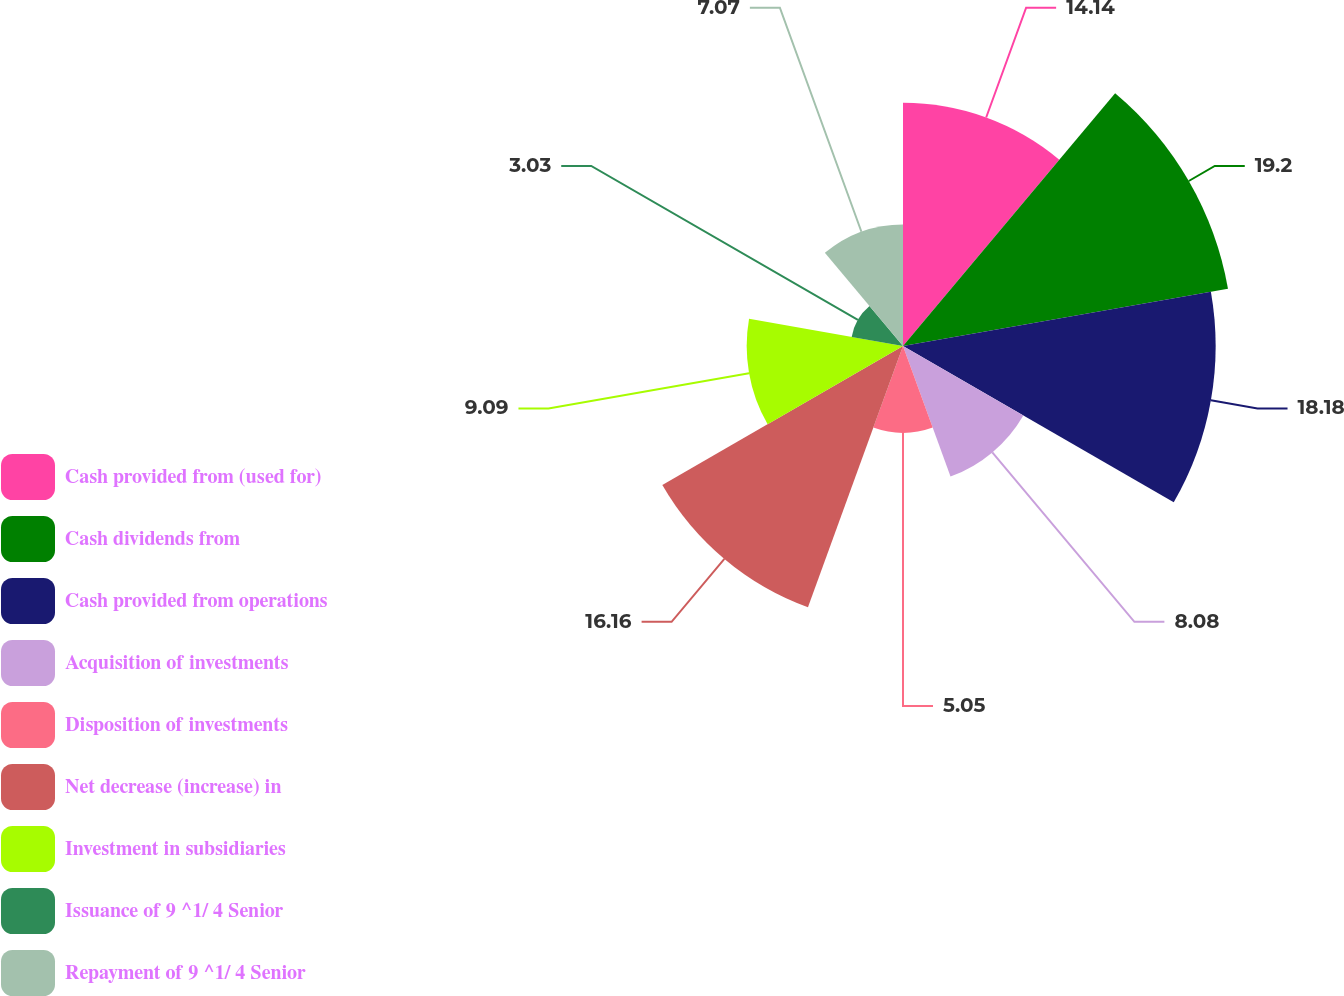<chart> <loc_0><loc_0><loc_500><loc_500><pie_chart><fcel>Cash provided from (used for)<fcel>Cash dividends from<fcel>Cash provided from operations<fcel>Acquisition of investments<fcel>Disposition of investments<fcel>Net decrease (increase) in<fcel>Investment in subsidiaries<fcel>Issuance of 9 ^1/ 4 Senior<fcel>Repayment of 9 ^1/ 4 Senior<nl><fcel>14.14%<fcel>19.19%<fcel>18.18%<fcel>8.08%<fcel>5.05%<fcel>16.16%<fcel>9.09%<fcel>3.03%<fcel>7.07%<nl></chart> 